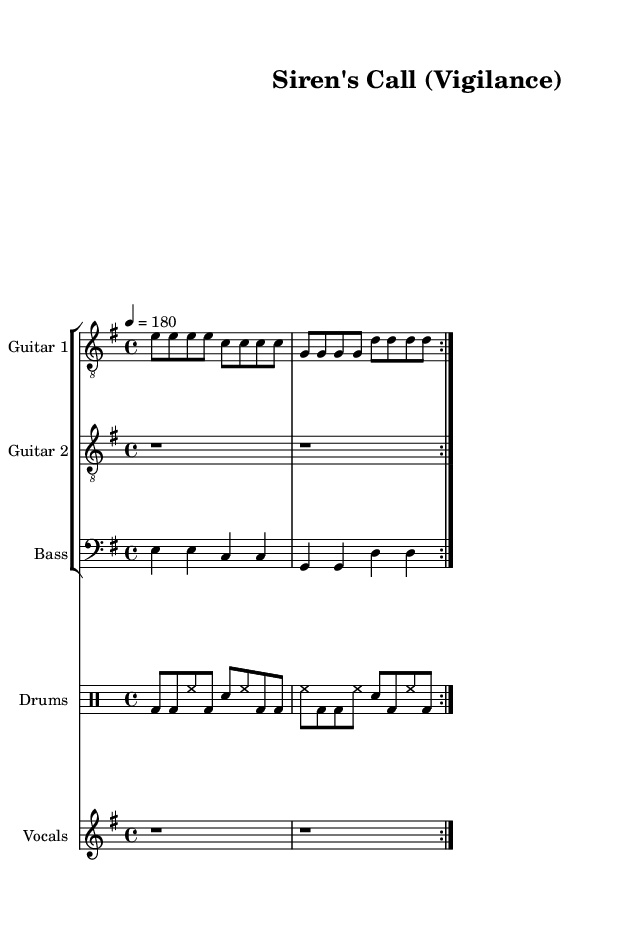What is the key signature of this music? The key signature indicated by the global settings is E minor, which includes one sharp (F#).
Answer: E minor What is the time signature of this piece? The time signature is shown as 4/4 in the global settings, meaning there are four beats in each measure.
Answer: 4/4 What is the tempo marking provided in the music? The tempo marking is set to 180 beats per minute, indicated in quarter note tempo.
Answer: 180 How many times is the guitar part repeated? The guitar part contains a repeat sign, indicating it is played twice in succession (notated as "volta 2").
Answer: 2 What is the primary theme of the lyrics in the song? The lyrics discuss themes of vigilance and unity in the face of danger, emphasizing duty and protection.
Answer: Vigilance and unity Which instrument plays the rhythms indicated by "bd" and "sn"? The "bd" (bass drum) and "sn" (snare drum) markings in the drumming part refer to the drums controlling the rhythm section.
Answer: Drums What do the repeated sections in the song structure suggest? The repeated sections in the song, such as the verses and chorus, contribute to the anthemic quality typical of thrash metal, emphasizing key messages and intensity.
Answer: Anthemic quality 